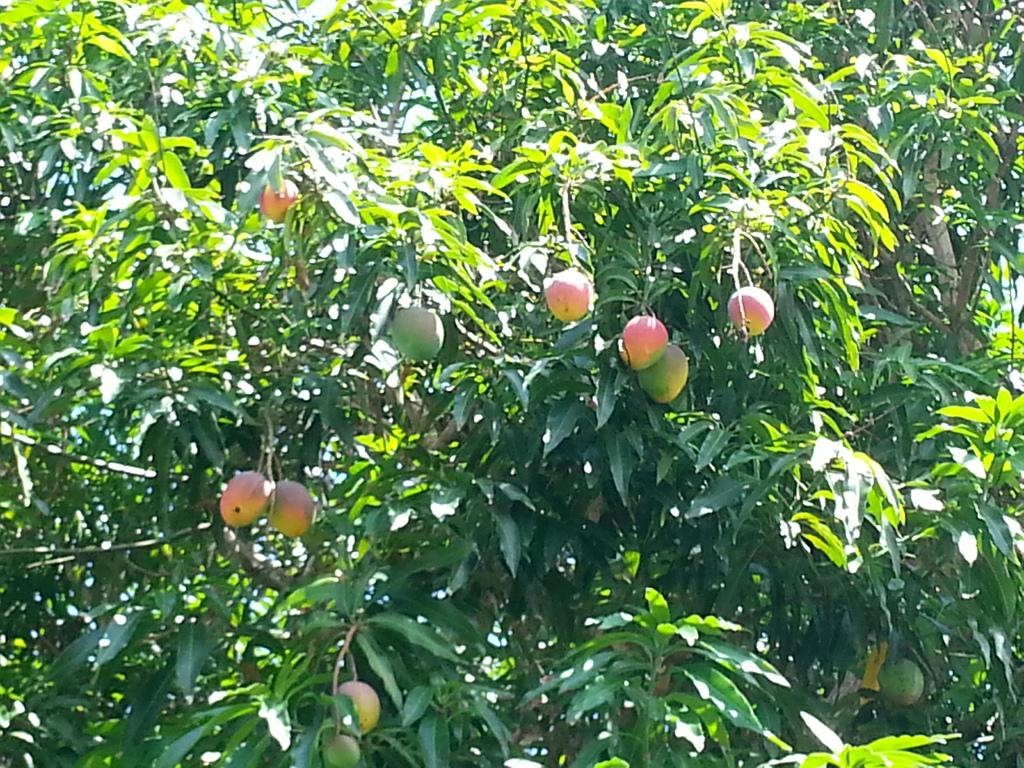What can be seen on the branches in the image? The branches have fruits and leaves. What type of vegetation do the branches belong to? The branches belong to trees, as indicated by the presence of leaves and fruits. What color is the blood on the tiger's fur in the image? There is no tiger or blood present in the image; it features branches of trees with fruits and leaves. 